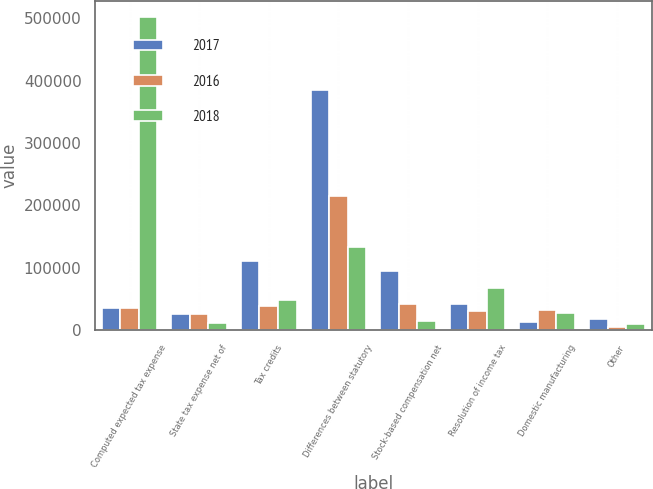Convert chart. <chart><loc_0><loc_0><loc_500><loc_500><stacked_bar_chart><ecel><fcel>Computed expected tax expense<fcel>State tax expense net of<fcel>Tax credits<fcel>Differences between statutory<fcel>Stock-based compensation net<fcel>Resolution of income tax<fcel>Domestic manufacturing<fcel>Other<nl><fcel>2017<fcel>35100<fcel>25214<fcel>110849<fcel>384393<fcel>95372<fcel>42432<fcel>13098<fcel>17795<nl><fcel>2016<fcel>35100<fcel>25131<fcel>38000<fcel>215490<fcel>42512<fcel>31358<fcel>32200<fcel>5171<nl><fcel>2018<fcel>502298<fcel>10636<fcel>48383<fcel>133778<fcel>15101<fcel>68003<fcel>26990<fcel>10129<nl></chart> 